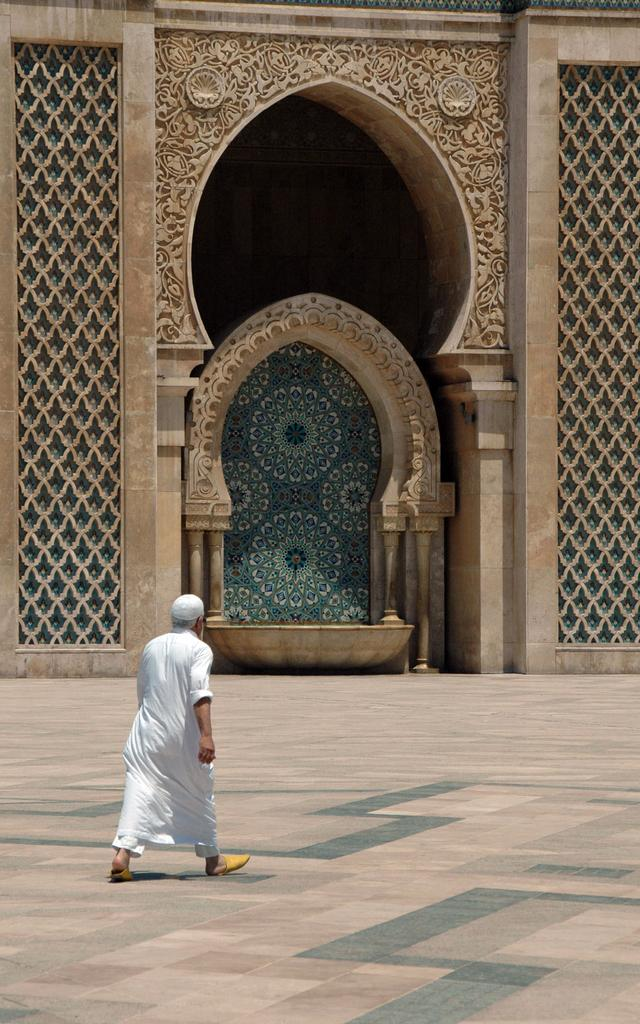What is the main subject of the image? There is a person in the image. What is the person wearing? The person is wearing a white dress and a white cap. What is the person doing in the image? The person is walking on the floor. What can be seen in the background of the image? There is an arch of a building in the background. What object is present on the floor? There is a vessel on the floor. What type of science experiment is being conducted in the image? There is no science experiment present in the image. How many beads are visible on the person's dress in the image? There are no beads visible on the person's dress in the image. 